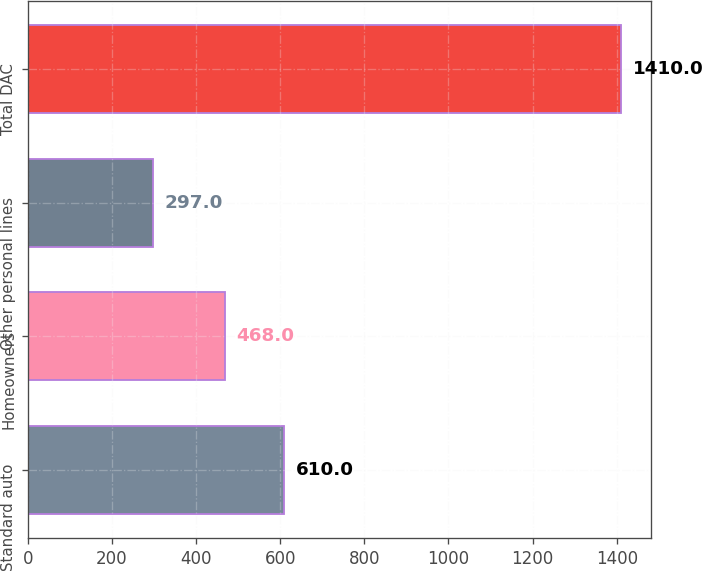<chart> <loc_0><loc_0><loc_500><loc_500><bar_chart><fcel>Standard auto<fcel>Homeowners<fcel>Other personal lines<fcel>Total DAC<nl><fcel>610<fcel>468<fcel>297<fcel>1410<nl></chart> 